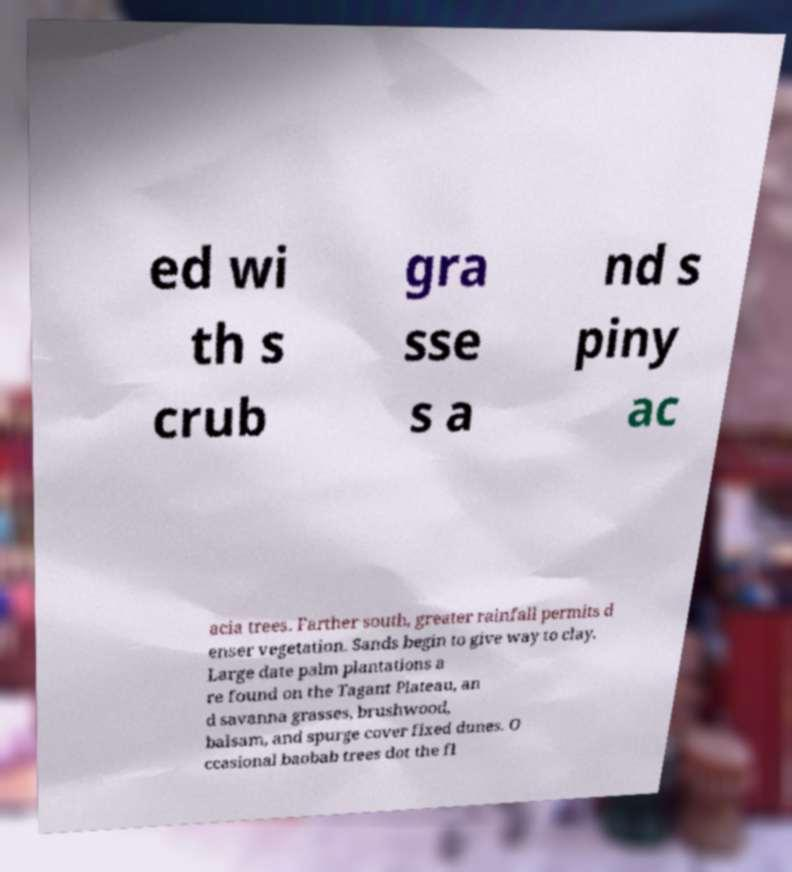Could you extract and type out the text from this image? ed wi th s crub gra sse s a nd s piny ac acia trees. Farther south, greater rainfall permits d enser vegetation. Sands begin to give way to clay. Large date palm plantations a re found on the Tagant Plateau, an d savanna grasses, brushwood, balsam, and spurge cover fixed dunes. O ccasional baobab trees dot the fl 